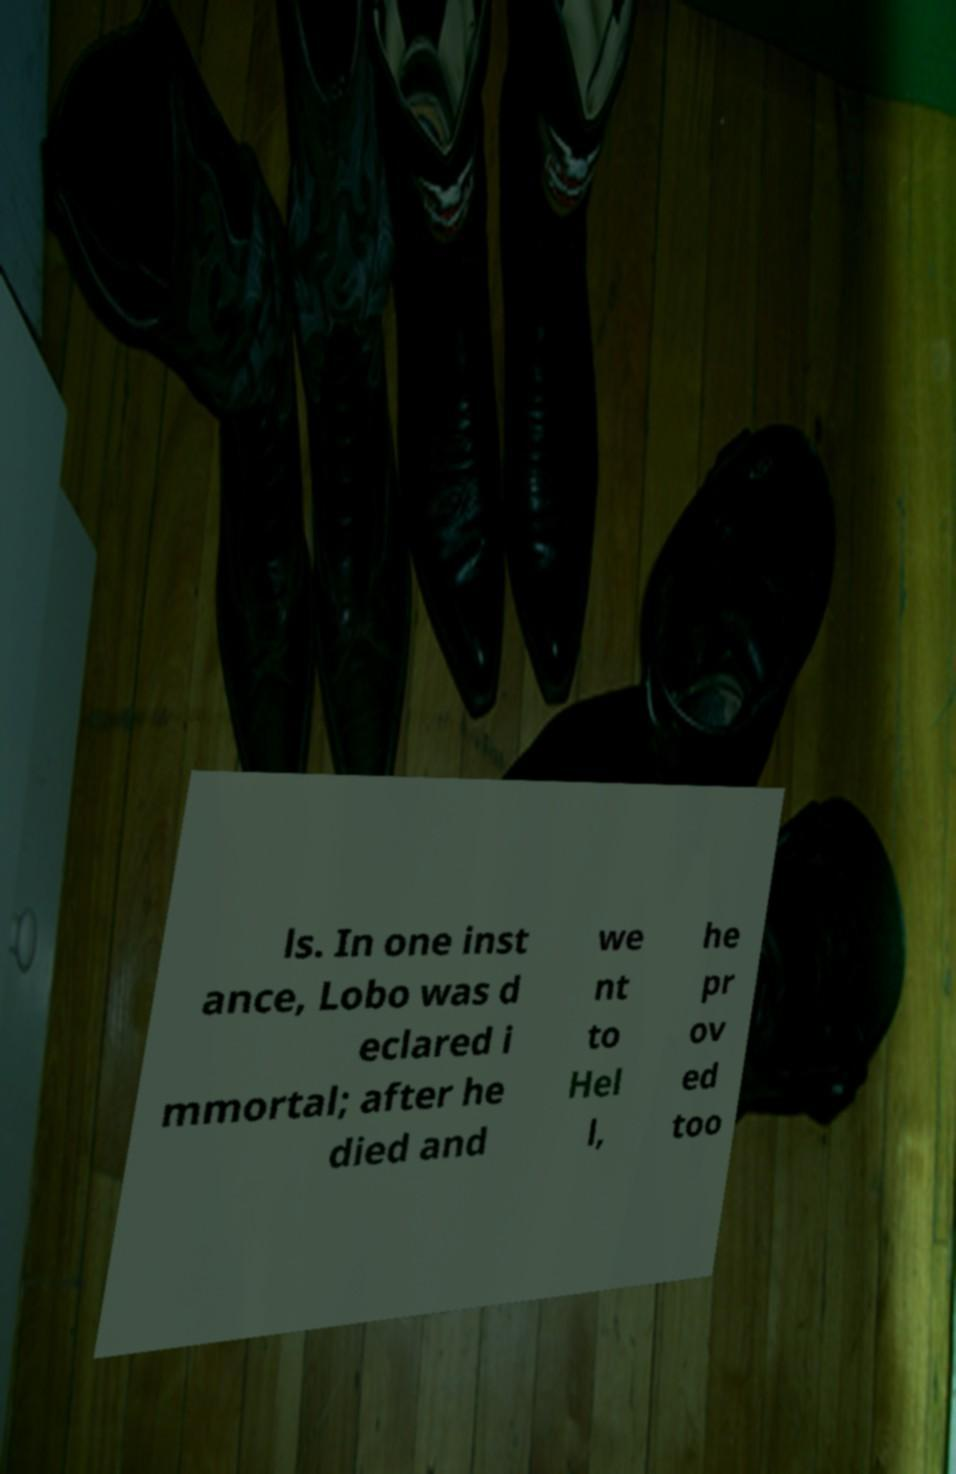Please read and relay the text visible in this image. What does it say? ls. In one inst ance, Lobo was d eclared i mmortal; after he died and we nt to Hel l, he pr ov ed too 